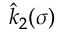Convert formula to latex. <formula><loc_0><loc_0><loc_500><loc_500>\hat { k } _ { 2 } ( \sigma )</formula> 